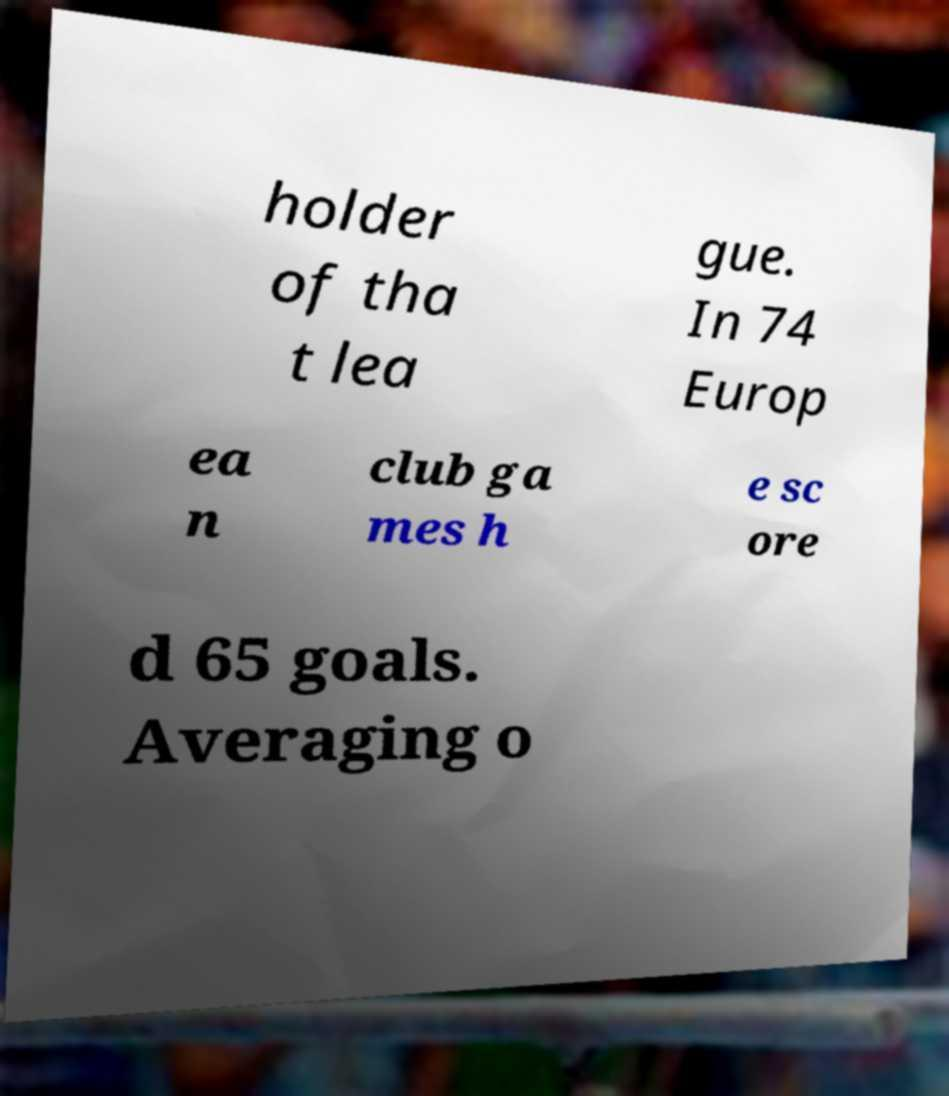Please read and relay the text visible in this image. What does it say? holder of tha t lea gue. In 74 Europ ea n club ga mes h e sc ore d 65 goals. Averaging o 